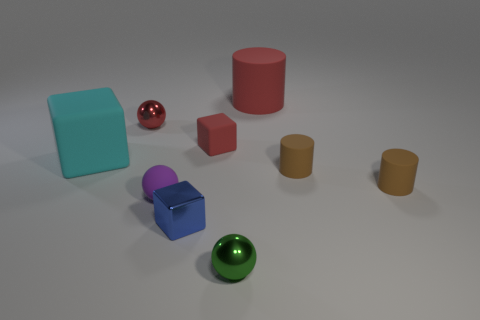Subtract all small red cubes. How many cubes are left? 2 Subtract 1 cylinders. How many cylinders are left? 2 Subtract all cylinders. How many objects are left? 6 Add 8 tiny gray metal balls. How many tiny gray metal balls exist? 8 Subtract all green spheres. How many spheres are left? 2 Subtract 0 gray cubes. How many objects are left? 9 Subtract all gray cylinders. Subtract all gray blocks. How many cylinders are left? 3 Subtract all gray cylinders. How many cyan blocks are left? 1 Subtract all tiny brown things. Subtract all big cyan blocks. How many objects are left? 6 Add 4 small red matte blocks. How many small red matte blocks are left? 5 